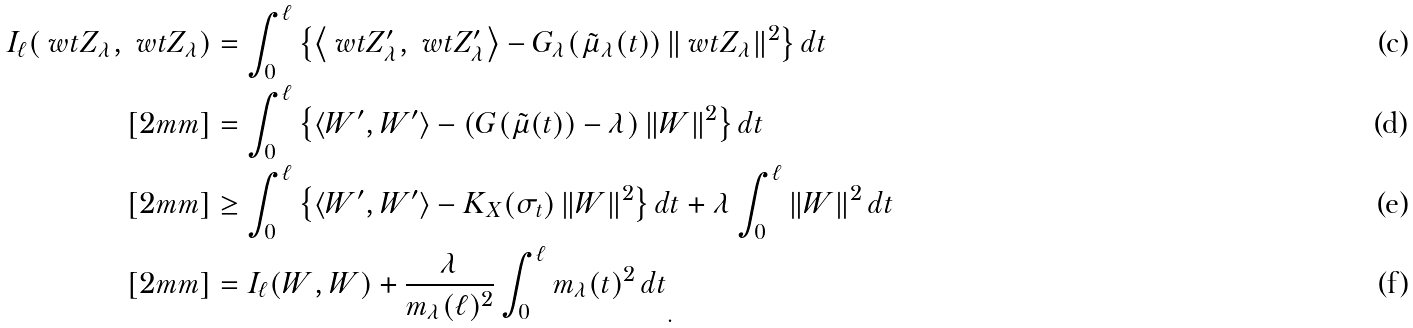<formula> <loc_0><loc_0><loc_500><loc_500>I _ { \ell } ( \ w t { Z } _ { \lambda } , \ w t { Z } _ { \lambda } ) & = \int ^ { \ell } _ { 0 } \left \{ \left \langle \ w t { Z } ^ { \prime } _ { \lambda } , \ w t { Z } ^ { \prime } _ { \lambda } \right \rangle - G _ { \lambda } ( \tilde { \mu } _ { \lambda } ( t ) ) \left \| \ w t { Z } _ { \lambda } \right \| ^ { 2 } \right \} d t \\ [ 2 m m ] & = \int ^ { \ell } _ { 0 } \left \{ \left \langle W ^ { \prime } , W ^ { \prime } \right \rangle - ( G ( \tilde { \mu } ( t ) ) - \lambda ) \left \| W \right \| ^ { 2 } \right \} d t \\ [ 2 m m ] & \geq \int ^ { \ell } _ { 0 } \left \{ \left \langle W ^ { \prime } , W ^ { \prime } \right \rangle - K _ { X } ( \sigma _ { t } ) \left \| W \right \| ^ { 2 } \right \} d t + \lambda \int ^ { \ell } _ { 0 } \left \| W \right \| ^ { 2 } d t \\ [ 2 m m ] & = { I _ { \ell } ( W , W ) + \frac { \lambda } { m _ { \lambda } ( \ell ) ^ { 2 } } \int _ { 0 } ^ { \ell } m _ { \lambda } ( t ) ^ { 2 } \, d t } _ { . }</formula> 